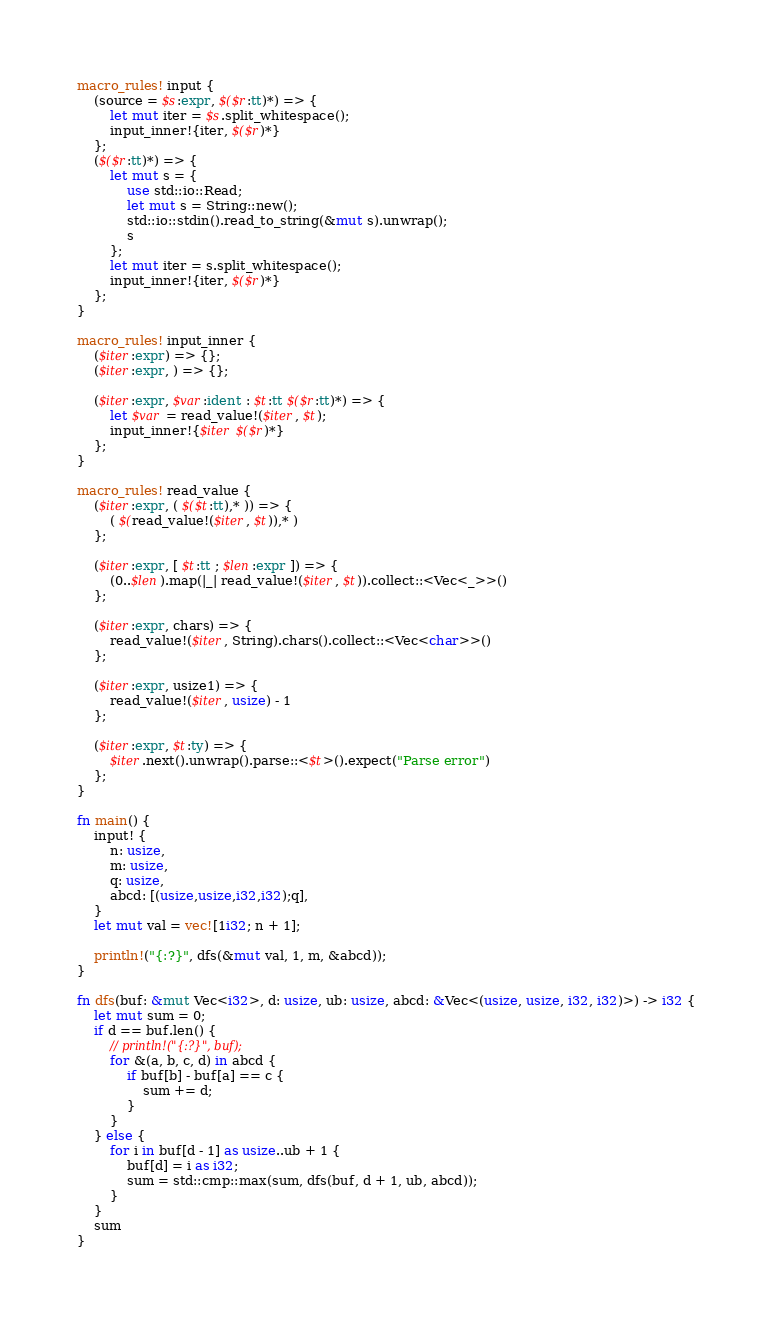Convert code to text. <code><loc_0><loc_0><loc_500><loc_500><_Rust_>macro_rules! input {
    (source = $s:expr, $($r:tt)*) => {
        let mut iter = $s.split_whitespace();
        input_inner!{iter, $($r)*}
    };
    ($($r:tt)*) => {
        let mut s = {
            use std::io::Read;
            let mut s = String::new();
            std::io::stdin().read_to_string(&mut s).unwrap();
            s
        };
        let mut iter = s.split_whitespace();
        input_inner!{iter, $($r)*}
    };
}

macro_rules! input_inner {
    ($iter:expr) => {};
    ($iter:expr, ) => {};

    ($iter:expr, $var:ident : $t:tt $($r:tt)*) => {
        let $var = read_value!($iter, $t);
        input_inner!{$iter $($r)*}
    };
}

macro_rules! read_value {
    ($iter:expr, ( $($t:tt),* )) => {
        ( $(read_value!($iter, $t)),* )
    };

    ($iter:expr, [ $t:tt ; $len:expr ]) => {
        (0..$len).map(|_| read_value!($iter, $t)).collect::<Vec<_>>()
    };

    ($iter:expr, chars) => {
        read_value!($iter, String).chars().collect::<Vec<char>>()
    };

    ($iter:expr, usize1) => {
        read_value!($iter, usize) - 1
    };

    ($iter:expr, $t:ty) => {
        $iter.next().unwrap().parse::<$t>().expect("Parse error")
    };
}

fn main() {
    input! {
        n: usize,
        m: usize,
        q: usize,
        abcd: [(usize,usize,i32,i32);q],
    }
    let mut val = vec![1i32; n + 1];

    println!("{:?}", dfs(&mut val, 1, m, &abcd));
}

fn dfs(buf: &mut Vec<i32>, d: usize, ub: usize, abcd: &Vec<(usize, usize, i32, i32)>) -> i32 {
    let mut sum = 0;
    if d == buf.len() {
        // println!("{:?}", buf);
        for &(a, b, c, d) in abcd {
            if buf[b] - buf[a] == c {
                sum += d;
            }
        }
    } else {
        for i in buf[d - 1] as usize..ub + 1 {
            buf[d] = i as i32;
            sum = std::cmp::max(sum, dfs(buf, d + 1, ub, abcd));
        }
    }
    sum
}
</code> 